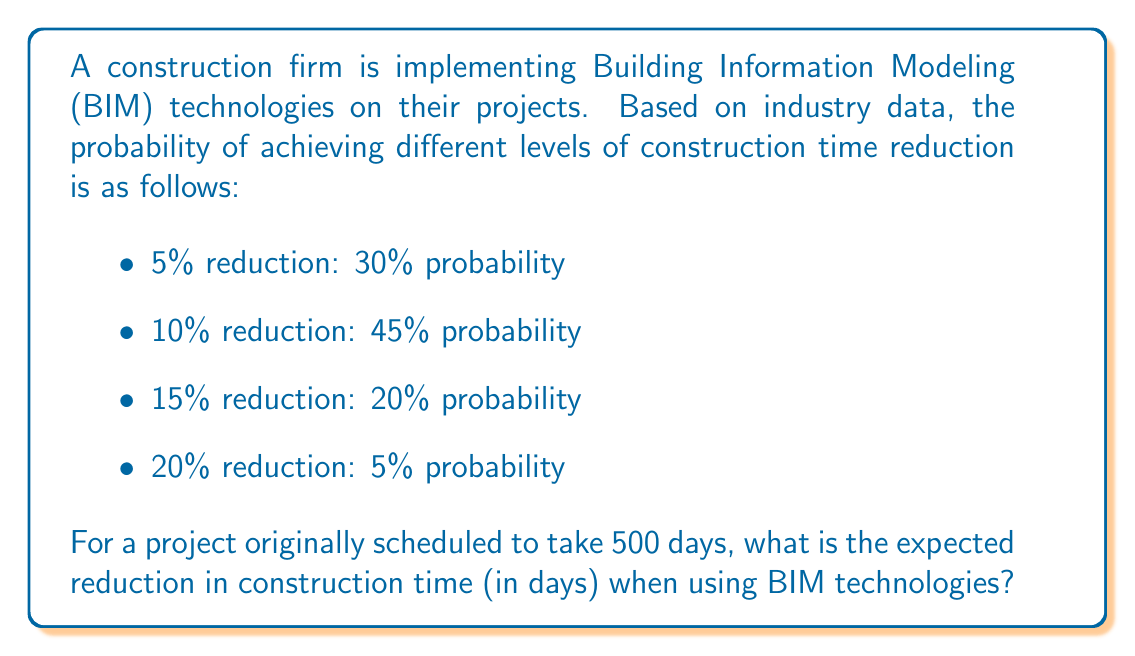Help me with this question. To solve this problem, we need to calculate the expected value of the reduction in construction time. Let's approach this step-by-step:

1) First, let's define our random variable X as the percentage reduction in construction time.

2) We're given the probability distribution of X:
   P(X = 5%) = 0.30
   P(X = 10%) = 0.45
   P(X = 15%) = 0.20
   P(X = 20%) = 0.05

3) The expected value of a discrete random variable is given by:

   $$E(X) = \sum_{i} x_i \cdot P(X = x_i)$$

4) Calculating E(X):
   $$E(X) = 5\% \cdot 0.30 + 10\% \cdot 0.45 + 15\% \cdot 0.20 + 20\% \cdot 0.05$$
   $$E(X) = 0.05 \cdot 0.30 + 0.10 \cdot 0.45 + 0.15 \cdot 0.20 + 0.20 \cdot 0.05$$
   $$E(X) = 0.015 + 0.045 + 0.030 + 0.010$$
   $$E(X) = 0.10 = 10\%$$

5) Now, we need to apply this expected percentage reduction to the original 500-day schedule:

   Expected reduction in days = 500 days × 10% = 500 × 0.10 = 50 days

Therefore, the expected reduction in construction time when using BIM technologies is 50 days.
Answer: 50 days 